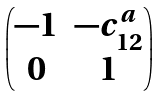<formula> <loc_0><loc_0><loc_500><loc_500>\begin{pmatrix} - 1 & - c _ { 1 2 } ^ { a } \\ 0 & 1 \end{pmatrix}</formula> 